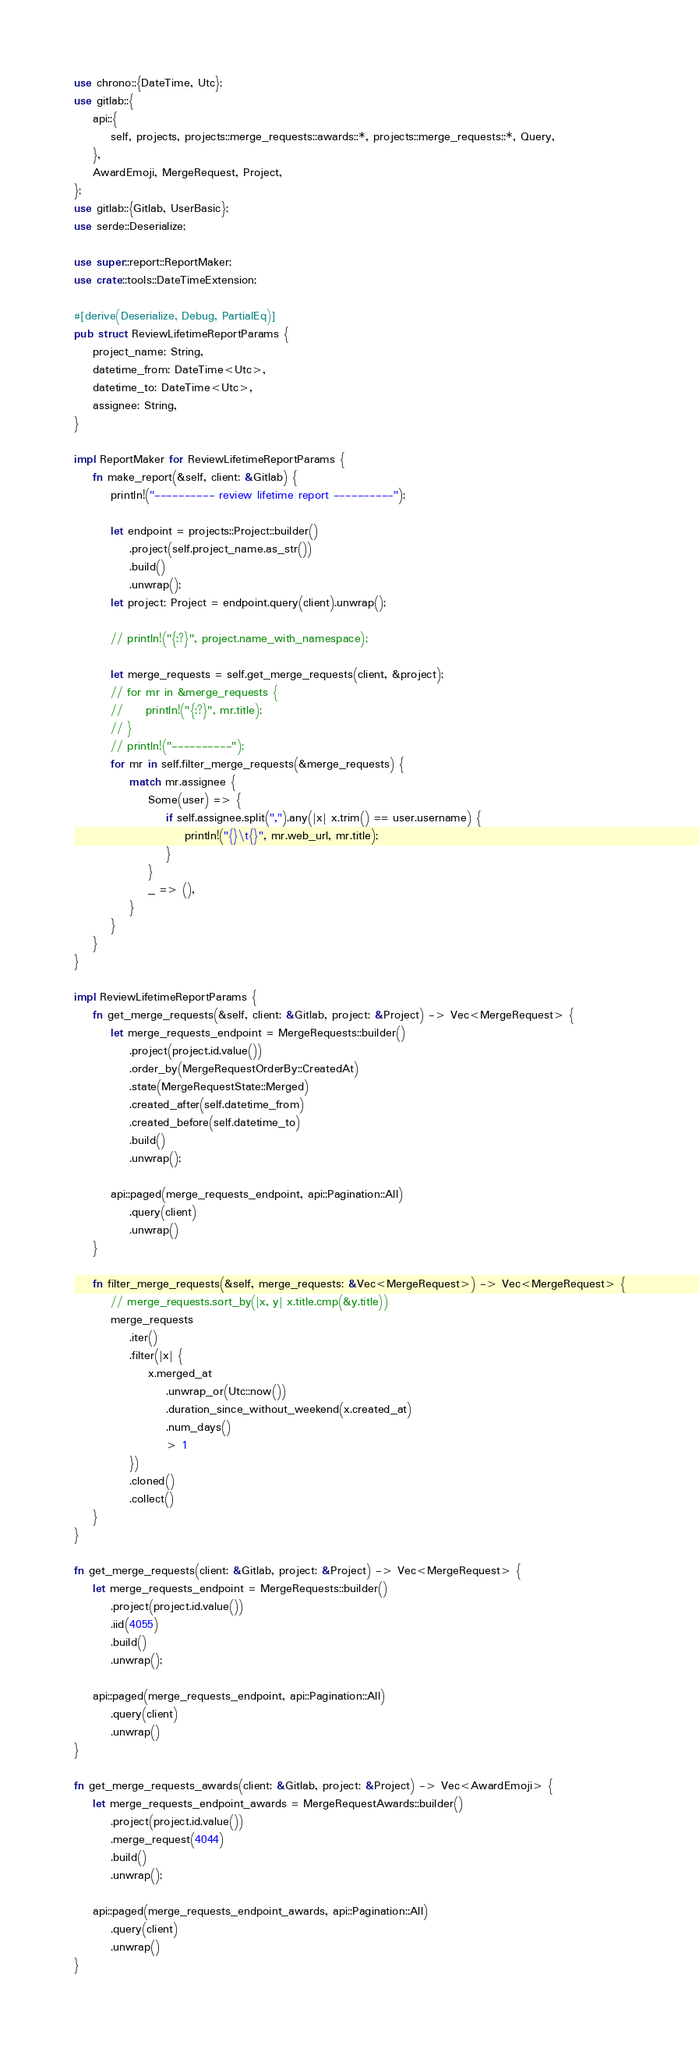Convert code to text. <code><loc_0><loc_0><loc_500><loc_500><_Rust_>use chrono::{DateTime, Utc};
use gitlab::{
    api::{
        self, projects, projects::merge_requests::awards::*, projects::merge_requests::*, Query,
    },
    AwardEmoji, MergeRequest, Project,
};
use gitlab::{Gitlab, UserBasic};
use serde::Deserialize;

use super::report::ReportMaker;
use crate::tools::DateTimeExtension;

#[derive(Deserialize, Debug, PartialEq)]
pub struct ReviewLifetimeReportParams {
    project_name: String,
    datetime_from: DateTime<Utc>,
    datetime_to: DateTime<Utc>,
    assignee: String,
}

impl ReportMaker for ReviewLifetimeReportParams {
    fn make_report(&self, client: &Gitlab) {
        println!("---------- review lifetime report ----------");

        let endpoint = projects::Project::builder()
            .project(self.project_name.as_str())
            .build()
            .unwrap();
        let project: Project = endpoint.query(client).unwrap();

        // println!("{:?}", project.name_with_namespace);

        let merge_requests = self.get_merge_requests(client, &project);
        // for mr in &merge_requests {
        //     println!("{:?}", mr.title);
        // }
        // println!("----------");
        for mr in self.filter_merge_requests(&merge_requests) {
            match mr.assignee {
                Some(user) => {
                    if self.assignee.split(",").any(|x| x.trim() == user.username) {
                        println!("{}\t{}", mr.web_url, mr.title);
                    }
                }
                _ => (),
            }
        }
    }
}

impl ReviewLifetimeReportParams {
    fn get_merge_requests(&self, client: &Gitlab, project: &Project) -> Vec<MergeRequest> {
        let merge_requests_endpoint = MergeRequests::builder()
            .project(project.id.value())
            .order_by(MergeRequestOrderBy::CreatedAt)
            .state(MergeRequestState::Merged)
            .created_after(self.datetime_from)
            .created_before(self.datetime_to)
            .build()
            .unwrap();

        api::paged(merge_requests_endpoint, api::Pagination::All)
            .query(client)
            .unwrap()
    }

    fn filter_merge_requests(&self, merge_requests: &Vec<MergeRequest>) -> Vec<MergeRequest> {
        // merge_requests.sort_by(|x, y| x.title.cmp(&y.title))
        merge_requests
            .iter()
            .filter(|x| {
                x.merged_at
                    .unwrap_or(Utc::now())
                    .duration_since_without_weekend(x.created_at)
                    .num_days()
                    > 1
            })
            .cloned()
            .collect()
    }
}

fn get_merge_requests(client: &Gitlab, project: &Project) -> Vec<MergeRequest> {
    let merge_requests_endpoint = MergeRequests::builder()
        .project(project.id.value())
        .iid(4055)
        .build()
        .unwrap();

    api::paged(merge_requests_endpoint, api::Pagination::All)
        .query(client)
        .unwrap()
}

fn get_merge_requests_awards(client: &Gitlab, project: &Project) -> Vec<AwardEmoji> {
    let merge_requests_endpoint_awards = MergeRequestAwards::builder()
        .project(project.id.value())
        .merge_request(4044)
        .build()
        .unwrap();

    api::paged(merge_requests_endpoint_awards, api::Pagination::All)
        .query(client)
        .unwrap()
}
</code> 